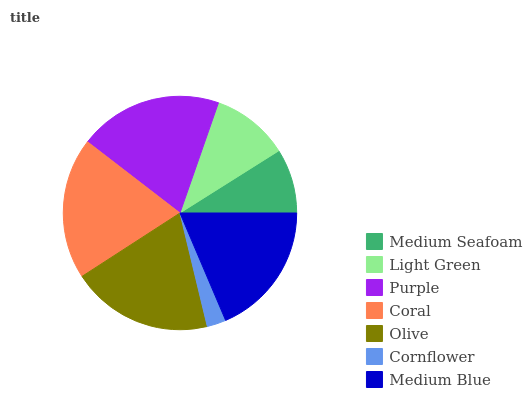Is Cornflower the minimum?
Answer yes or no. Yes. Is Purple the maximum?
Answer yes or no. Yes. Is Light Green the minimum?
Answer yes or no. No. Is Light Green the maximum?
Answer yes or no. No. Is Light Green greater than Medium Seafoam?
Answer yes or no. Yes. Is Medium Seafoam less than Light Green?
Answer yes or no. Yes. Is Medium Seafoam greater than Light Green?
Answer yes or no. No. Is Light Green less than Medium Seafoam?
Answer yes or no. No. Is Medium Blue the high median?
Answer yes or no. Yes. Is Medium Blue the low median?
Answer yes or no. Yes. Is Olive the high median?
Answer yes or no. No. Is Cornflower the low median?
Answer yes or no. No. 